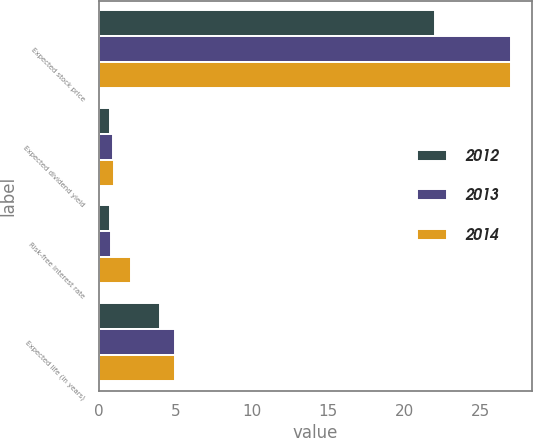Convert chart to OTSL. <chart><loc_0><loc_0><loc_500><loc_500><stacked_bar_chart><ecel><fcel>Expected stock price<fcel>Expected dividend yield<fcel>Risk-free interest rate<fcel>Expected life (in years)<nl><fcel>2012<fcel>22<fcel>0.7<fcel>0.7<fcel>4<nl><fcel>2013<fcel>27<fcel>0.9<fcel>0.8<fcel>5<nl><fcel>2014<fcel>27<fcel>1<fcel>2.1<fcel>5<nl></chart> 